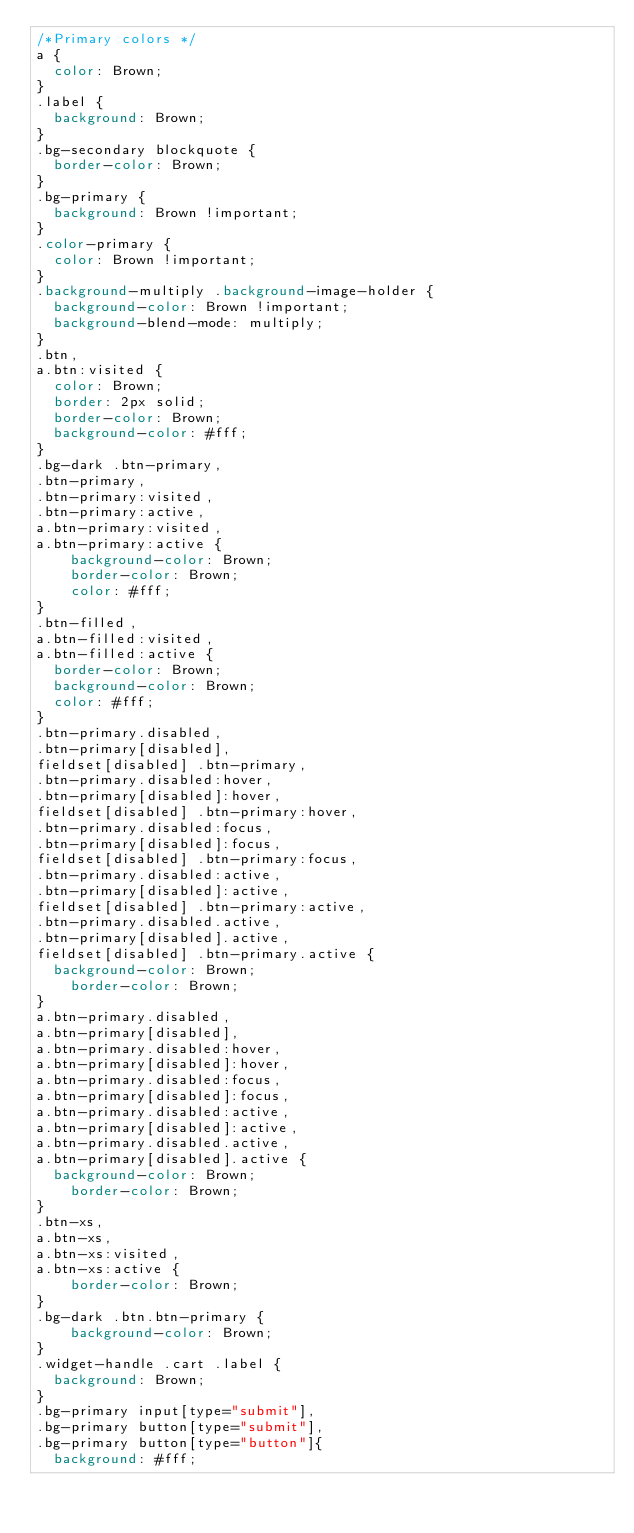<code> <loc_0><loc_0><loc_500><loc_500><_CSS_>/*Primary colors */
a {
  color: Brown;
}
.label {
  background: Brown;
}
.bg-secondary blockquote {
  border-color: Brown;
}
.bg-primary {
  background: Brown !important;
}
.color-primary {
  color: Brown !important;
}
.background-multiply .background-image-holder {
  background-color: Brown !important;
  background-blend-mode: multiply;
}
.btn,
a.btn:visited {
  color: Brown;
  border: 2px solid;
  border-color: Brown;
  background-color: #fff;
}
.bg-dark .btn-primary,
.btn-primary,
.btn-primary:visited,
.btn-primary:active,
a.btn-primary:visited,
a.btn-primary:active {
    background-color: Brown;
    border-color: Brown;
    color: #fff;
}
.btn-filled,
a.btn-filled:visited,
a.btn-filled:active {
  border-color: Brown;
  background-color: Brown;
  color: #fff;
}
.btn-primary.disabled, 
.btn-primary[disabled], 
fieldset[disabled] .btn-primary, 
.btn-primary.disabled:hover, 
.btn-primary[disabled]:hover, 
fieldset[disabled] .btn-primary:hover, 
.btn-primary.disabled:focus, 
.btn-primary[disabled]:focus, 
fieldset[disabled] .btn-primary:focus, 
.btn-primary.disabled:active, 
.btn-primary[disabled]:active, 
fieldset[disabled] .btn-primary:active, 
.btn-primary.disabled.active, 
.btn-primary[disabled].active, 
fieldset[disabled] .btn-primary.active { 
	background-color: Brown;
    border-color: Brown;
}
a.btn-primary.disabled, 
a.btn-primary[disabled], 
a.btn-primary.disabled:hover, 
a.btn-primary[disabled]:hover, 
a.btn-primary.disabled:focus, 
a.btn-primary[disabled]:focus, 
a.btn-primary.disabled:active, 
a.btn-primary[disabled]:active, 
a.btn-primary.disabled.active, 
a.btn-primary[disabled].active { 
	background-color: Brown;
    border-color: Brown;
}
.btn-xs,
a.btn-xs,
a.btn-xs:visited,
a.btn-xs:active {
    border-color: Brown;
}
.bg-dark .btn.btn-primary {
  	background-color: Brown;
}
.widget-handle .cart .label {
  background: Brown;
}
.bg-primary input[type="submit"],
.bg-primary button[type="submit"],
.bg-primary button[type="button"]{
  background: #fff;</code> 